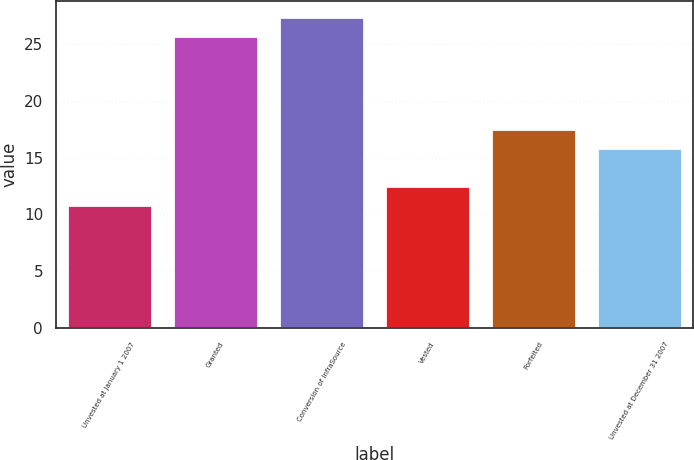Convert chart. <chart><loc_0><loc_0><loc_500><loc_500><bar_chart><fcel>Unvested at January 1 2007<fcel>Granted<fcel>Conversion of InfraSource<fcel>Vested<fcel>Forfeited<fcel>Unvested at December 31 2007<nl><fcel>10.85<fcel>25.72<fcel>27.39<fcel>12.5<fcel>17.49<fcel>15.84<nl></chart> 